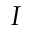Convert formula to latex. <formula><loc_0><loc_0><loc_500><loc_500>I</formula> 